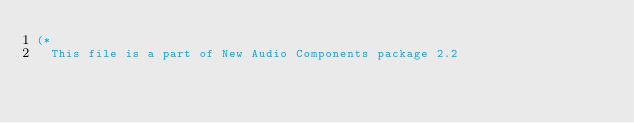<code> <loc_0><loc_0><loc_500><loc_500><_Pascal_>(*
  This file is a part of New Audio Components package 2.2</code> 